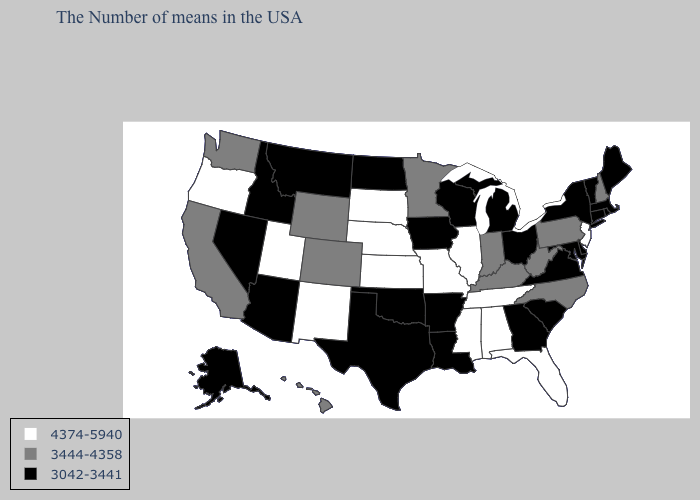What is the value of Wisconsin?
Concise answer only. 3042-3441. Does New Jersey have the highest value in the Northeast?
Give a very brief answer. Yes. Among the states that border North Carolina , does Georgia have the highest value?
Keep it brief. No. What is the highest value in the South ?
Quick response, please. 4374-5940. Does the map have missing data?
Short answer required. No. Name the states that have a value in the range 3042-3441?
Quick response, please. Maine, Massachusetts, Rhode Island, Vermont, Connecticut, New York, Delaware, Maryland, Virginia, South Carolina, Ohio, Georgia, Michigan, Wisconsin, Louisiana, Arkansas, Iowa, Oklahoma, Texas, North Dakota, Montana, Arizona, Idaho, Nevada, Alaska. How many symbols are there in the legend?
Be succinct. 3. Does Wisconsin have a lower value than Kansas?
Give a very brief answer. Yes. What is the value of New Hampshire?
Keep it brief. 3444-4358. Name the states that have a value in the range 3042-3441?
Be succinct. Maine, Massachusetts, Rhode Island, Vermont, Connecticut, New York, Delaware, Maryland, Virginia, South Carolina, Ohio, Georgia, Michigan, Wisconsin, Louisiana, Arkansas, Iowa, Oklahoma, Texas, North Dakota, Montana, Arizona, Idaho, Nevada, Alaska. Among the states that border New York , does New Jersey have the highest value?
Give a very brief answer. Yes. Does South Dakota have a higher value than Alaska?
Write a very short answer. Yes. Among the states that border Oregon , which have the lowest value?
Short answer required. Idaho, Nevada. Which states have the lowest value in the Northeast?
Short answer required. Maine, Massachusetts, Rhode Island, Vermont, Connecticut, New York. Name the states that have a value in the range 3444-4358?
Write a very short answer. New Hampshire, Pennsylvania, North Carolina, West Virginia, Kentucky, Indiana, Minnesota, Wyoming, Colorado, California, Washington, Hawaii. 